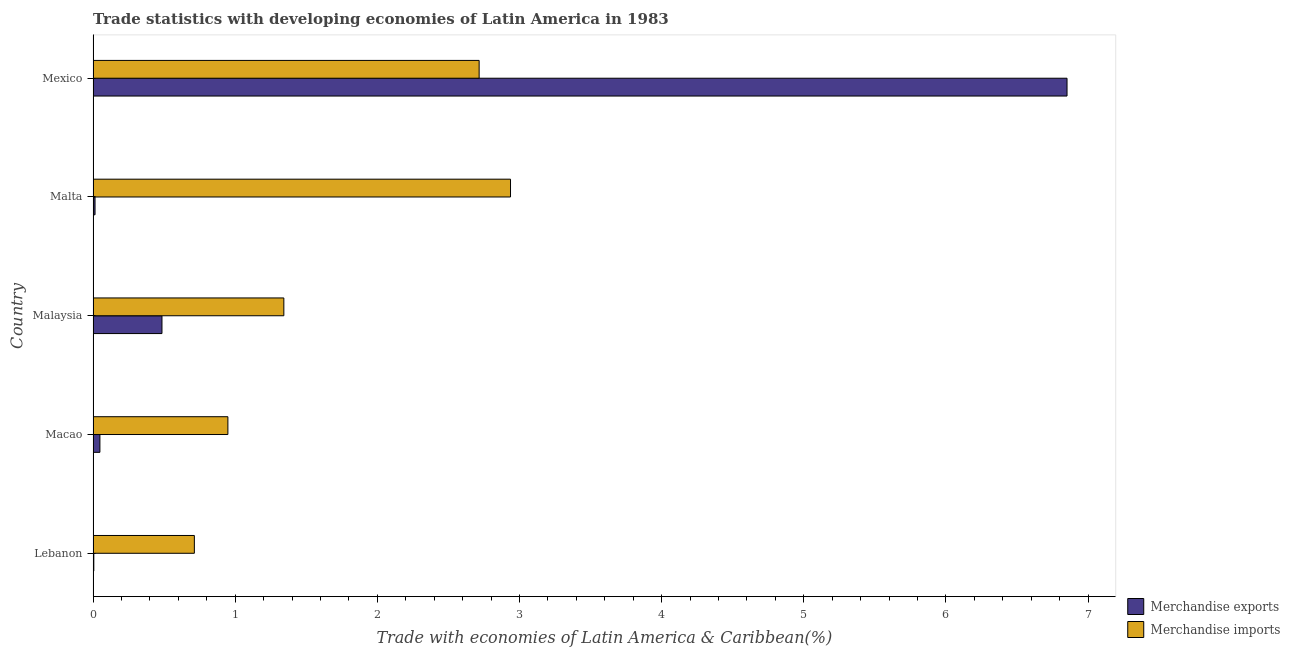Are the number of bars on each tick of the Y-axis equal?
Ensure brevity in your answer.  Yes. How many bars are there on the 2nd tick from the top?
Keep it short and to the point. 2. How many bars are there on the 2nd tick from the bottom?
Provide a succinct answer. 2. What is the label of the 2nd group of bars from the top?
Offer a terse response. Malta. What is the merchandise imports in Malta?
Your answer should be very brief. 2.94. Across all countries, what is the maximum merchandise exports?
Your answer should be compact. 6.85. Across all countries, what is the minimum merchandise exports?
Make the answer very short. 0.01. In which country was the merchandise exports maximum?
Keep it short and to the point. Mexico. In which country was the merchandise exports minimum?
Offer a very short reply. Lebanon. What is the total merchandise imports in the graph?
Provide a succinct answer. 8.66. What is the difference between the merchandise exports in Macao and that in Malaysia?
Keep it short and to the point. -0.44. What is the difference between the merchandise exports in Mexico and the merchandise imports in Malta?
Ensure brevity in your answer.  3.92. What is the average merchandise imports per country?
Your response must be concise. 1.73. What is the difference between the merchandise exports and merchandise imports in Lebanon?
Your response must be concise. -0.71. In how many countries, is the merchandise imports greater than 1.2 %?
Keep it short and to the point. 3. What is the ratio of the merchandise imports in Lebanon to that in Malta?
Ensure brevity in your answer.  0.24. Is the merchandise exports in Macao less than that in Malaysia?
Your response must be concise. Yes. Is the difference between the merchandise imports in Malaysia and Malta greater than the difference between the merchandise exports in Malaysia and Malta?
Your response must be concise. No. What is the difference between the highest and the second highest merchandise imports?
Your answer should be compact. 0.22. What is the difference between the highest and the lowest merchandise imports?
Your answer should be very brief. 2.22. Is the sum of the merchandise imports in Macao and Malaysia greater than the maximum merchandise exports across all countries?
Your answer should be very brief. No. What does the 2nd bar from the bottom in Lebanon represents?
Your answer should be very brief. Merchandise imports. How many countries are there in the graph?
Your response must be concise. 5. What is the difference between two consecutive major ticks on the X-axis?
Keep it short and to the point. 1. Are the values on the major ticks of X-axis written in scientific E-notation?
Offer a very short reply. No. Where does the legend appear in the graph?
Provide a short and direct response. Bottom right. How many legend labels are there?
Make the answer very short. 2. How are the legend labels stacked?
Offer a terse response. Vertical. What is the title of the graph?
Provide a short and direct response. Trade statistics with developing economies of Latin America in 1983. Does "Nitrous oxide" appear as one of the legend labels in the graph?
Make the answer very short. No. What is the label or title of the X-axis?
Keep it short and to the point. Trade with economies of Latin America & Caribbean(%). What is the Trade with economies of Latin America & Caribbean(%) in Merchandise exports in Lebanon?
Offer a terse response. 0.01. What is the Trade with economies of Latin America & Caribbean(%) in Merchandise imports in Lebanon?
Provide a succinct answer. 0.71. What is the Trade with economies of Latin America & Caribbean(%) in Merchandise exports in Macao?
Ensure brevity in your answer.  0.05. What is the Trade with economies of Latin America & Caribbean(%) in Merchandise imports in Macao?
Ensure brevity in your answer.  0.95. What is the Trade with economies of Latin America & Caribbean(%) of Merchandise exports in Malaysia?
Your answer should be compact. 0.48. What is the Trade with economies of Latin America & Caribbean(%) in Merchandise imports in Malaysia?
Make the answer very short. 1.34. What is the Trade with economies of Latin America & Caribbean(%) in Merchandise exports in Malta?
Your answer should be compact. 0.01. What is the Trade with economies of Latin America & Caribbean(%) in Merchandise imports in Malta?
Make the answer very short. 2.94. What is the Trade with economies of Latin America & Caribbean(%) of Merchandise exports in Mexico?
Your answer should be very brief. 6.85. What is the Trade with economies of Latin America & Caribbean(%) of Merchandise imports in Mexico?
Your answer should be very brief. 2.72. Across all countries, what is the maximum Trade with economies of Latin America & Caribbean(%) of Merchandise exports?
Provide a succinct answer. 6.85. Across all countries, what is the maximum Trade with economies of Latin America & Caribbean(%) of Merchandise imports?
Your response must be concise. 2.94. Across all countries, what is the minimum Trade with economies of Latin America & Caribbean(%) in Merchandise exports?
Make the answer very short. 0.01. Across all countries, what is the minimum Trade with economies of Latin America & Caribbean(%) in Merchandise imports?
Provide a succinct answer. 0.71. What is the total Trade with economies of Latin America & Caribbean(%) of Merchandise exports in the graph?
Your answer should be very brief. 7.4. What is the total Trade with economies of Latin America & Caribbean(%) in Merchandise imports in the graph?
Provide a short and direct response. 8.66. What is the difference between the Trade with economies of Latin America & Caribbean(%) of Merchandise exports in Lebanon and that in Macao?
Provide a short and direct response. -0.04. What is the difference between the Trade with economies of Latin America & Caribbean(%) of Merchandise imports in Lebanon and that in Macao?
Your response must be concise. -0.24. What is the difference between the Trade with economies of Latin America & Caribbean(%) in Merchandise exports in Lebanon and that in Malaysia?
Make the answer very short. -0.48. What is the difference between the Trade with economies of Latin America & Caribbean(%) in Merchandise imports in Lebanon and that in Malaysia?
Ensure brevity in your answer.  -0.63. What is the difference between the Trade with economies of Latin America & Caribbean(%) in Merchandise exports in Lebanon and that in Malta?
Ensure brevity in your answer.  -0.01. What is the difference between the Trade with economies of Latin America & Caribbean(%) in Merchandise imports in Lebanon and that in Malta?
Your answer should be very brief. -2.22. What is the difference between the Trade with economies of Latin America & Caribbean(%) in Merchandise exports in Lebanon and that in Mexico?
Offer a very short reply. -6.85. What is the difference between the Trade with economies of Latin America & Caribbean(%) in Merchandise imports in Lebanon and that in Mexico?
Offer a terse response. -2. What is the difference between the Trade with economies of Latin America & Caribbean(%) in Merchandise exports in Macao and that in Malaysia?
Offer a terse response. -0.44. What is the difference between the Trade with economies of Latin America & Caribbean(%) in Merchandise imports in Macao and that in Malaysia?
Offer a very short reply. -0.39. What is the difference between the Trade with economies of Latin America & Caribbean(%) in Merchandise exports in Macao and that in Malta?
Your response must be concise. 0.03. What is the difference between the Trade with economies of Latin America & Caribbean(%) in Merchandise imports in Macao and that in Malta?
Offer a very short reply. -1.99. What is the difference between the Trade with economies of Latin America & Caribbean(%) of Merchandise exports in Macao and that in Mexico?
Provide a short and direct response. -6.8. What is the difference between the Trade with economies of Latin America & Caribbean(%) in Merchandise imports in Macao and that in Mexico?
Your response must be concise. -1.77. What is the difference between the Trade with economies of Latin America & Caribbean(%) of Merchandise exports in Malaysia and that in Malta?
Offer a terse response. 0.47. What is the difference between the Trade with economies of Latin America & Caribbean(%) of Merchandise imports in Malaysia and that in Malta?
Offer a very short reply. -1.59. What is the difference between the Trade with economies of Latin America & Caribbean(%) of Merchandise exports in Malaysia and that in Mexico?
Your answer should be very brief. -6.37. What is the difference between the Trade with economies of Latin America & Caribbean(%) of Merchandise imports in Malaysia and that in Mexico?
Provide a succinct answer. -1.37. What is the difference between the Trade with economies of Latin America & Caribbean(%) of Merchandise exports in Malta and that in Mexico?
Provide a succinct answer. -6.84. What is the difference between the Trade with economies of Latin America & Caribbean(%) of Merchandise imports in Malta and that in Mexico?
Ensure brevity in your answer.  0.22. What is the difference between the Trade with economies of Latin America & Caribbean(%) of Merchandise exports in Lebanon and the Trade with economies of Latin America & Caribbean(%) of Merchandise imports in Macao?
Your answer should be compact. -0.94. What is the difference between the Trade with economies of Latin America & Caribbean(%) in Merchandise exports in Lebanon and the Trade with economies of Latin America & Caribbean(%) in Merchandise imports in Malaysia?
Offer a very short reply. -1.34. What is the difference between the Trade with economies of Latin America & Caribbean(%) in Merchandise exports in Lebanon and the Trade with economies of Latin America & Caribbean(%) in Merchandise imports in Malta?
Give a very brief answer. -2.93. What is the difference between the Trade with economies of Latin America & Caribbean(%) of Merchandise exports in Lebanon and the Trade with economies of Latin America & Caribbean(%) of Merchandise imports in Mexico?
Provide a short and direct response. -2.71. What is the difference between the Trade with economies of Latin America & Caribbean(%) in Merchandise exports in Macao and the Trade with economies of Latin America & Caribbean(%) in Merchandise imports in Malaysia?
Offer a very short reply. -1.29. What is the difference between the Trade with economies of Latin America & Caribbean(%) in Merchandise exports in Macao and the Trade with economies of Latin America & Caribbean(%) in Merchandise imports in Malta?
Provide a succinct answer. -2.89. What is the difference between the Trade with economies of Latin America & Caribbean(%) of Merchandise exports in Macao and the Trade with economies of Latin America & Caribbean(%) of Merchandise imports in Mexico?
Your response must be concise. -2.67. What is the difference between the Trade with economies of Latin America & Caribbean(%) of Merchandise exports in Malaysia and the Trade with economies of Latin America & Caribbean(%) of Merchandise imports in Malta?
Give a very brief answer. -2.45. What is the difference between the Trade with economies of Latin America & Caribbean(%) in Merchandise exports in Malaysia and the Trade with economies of Latin America & Caribbean(%) in Merchandise imports in Mexico?
Your answer should be very brief. -2.23. What is the difference between the Trade with economies of Latin America & Caribbean(%) in Merchandise exports in Malta and the Trade with economies of Latin America & Caribbean(%) in Merchandise imports in Mexico?
Make the answer very short. -2.7. What is the average Trade with economies of Latin America & Caribbean(%) in Merchandise exports per country?
Give a very brief answer. 1.48. What is the average Trade with economies of Latin America & Caribbean(%) in Merchandise imports per country?
Make the answer very short. 1.73. What is the difference between the Trade with economies of Latin America & Caribbean(%) of Merchandise exports and Trade with economies of Latin America & Caribbean(%) of Merchandise imports in Lebanon?
Keep it short and to the point. -0.71. What is the difference between the Trade with economies of Latin America & Caribbean(%) in Merchandise exports and Trade with economies of Latin America & Caribbean(%) in Merchandise imports in Macao?
Make the answer very short. -0.9. What is the difference between the Trade with economies of Latin America & Caribbean(%) of Merchandise exports and Trade with economies of Latin America & Caribbean(%) of Merchandise imports in Malaysia?
Ensure brevity in your answer.  -0.86. What is the difference between the Trade with economies of Latin America & Caribbean(%) in Merchandise exports and Trade with economies of Latin America & Caribbean(%) in Merchandise imports in Malta?
Offer a very short reply. -2.92. What is the difference between the Trade with economies of Latin America & Caribbean(%) of Merchandise exports and Trade with economies of Latin America & Caribbean(%) of Merchandise imports in Mexico?
Your answer should be compact. 4.14. What is the ratio of the Trade with economies of Latin America & Caribbean(%) in Merchandise exports in Lebanon to that in Macao?
Your answer should be very brief. 0.11. What is the ratio of the Trade with economies of Latin America & Caribbean(%) of Merchandise imports in Lebanon to that in Macao?
Make the answer very short. 0.75. What is the ratio of the Trade with economies of Latin America & Caribbean(%) of Merchandise exports in Lebanon to that in Malaysia?
Provide a short and direct response. 0.01. What is the ratio of the Trade with economies of Latin America & Caribbean(%) of Merchandise imports in Lebanon to that in Malaysia?
Your answer should be compact. 0.53. What is the ratio of the Trade with economies of Latin America & Caribbean(%) in Merchandise exports in Lebanon to that in Malta?
Your answer should be compact. 0.37. What is the ratio of the Trade with economies of Latin America & Caribbean(%) of Merchandise imports in Lebanon to that in Malta?
Keep it short and to the point. 0.24. What is the ratio of the Trade with economies of Latin America & Caribbean(%) in Merchandise exports in Lebanon to that in Mexico?
Make the answer very short. 0. What is the ratio of the Trade with economies of Latin America & Caribbean(%) in Merchandise imports in Lebanon to that in Mexico?
Provide a short and direct response. 0.26. What is the ratio of the Trade with economies of Latin America & Caribbean(%) in Merchandise exports in Macao to that in Malaysia?
Give a very brief answer. 0.1. What is the ratio of the Trade with economies of Latin America & Caribbean(%) in Merchandise imports in Macao to that in Malaysia?
Offer a very short reply. 0.71. What is the ratio of the Trade with economies of Latin America & Caribbean(%) of Merchandise exports in Macao to that in Malta?
Keep it short and to the point. 3.49. What is the ratio of the Trade with economies of Latin America & Caribbean(%) in Merchandise imports in Macao to that in Malta?
Your response must be concise. 0.32. What is the ratio of the Trade with economies of Latin America & Caribbean(%) of Merchandise exports in Macao to that in Mexico?
Your answer should be very brief. 0.01. What is the ratio of the Trade with economies of Latin America & Caribbean(%) in Merchandise imports in Macao to that in Mexico?
Your answer should be very brief. 0.35. What is the ratio of the Trade with economies of Latin America & Caribbean(%) in Merchandise exports in Malaysia to that in Malta?
Your response must be concise. 35.22. What is the ratio of the Trade with economies of Latin America & Caribbean(%) in Merchandise imports in Malaysia to that in Malta?
Provide a short and direct response. 0.46. What is the ratio of the Trade with economies of Latin America & Caribbean(%) of Merchandise exports in Malaysia to that in Mexico?
Provide a succinct answer. 0.07. What is the ratio of the Trade with economies of Latin America & Caribbean(%) in Merchandise imports in Malaysia to that in Mexico?
Give a very brief answer. 0.49. What is the ratio of the Trade with economies of Latin America & Caribbean(%) of Merchandise exports in Malta to that in Mexico?
Ensure brevity in your answer.  0. What is the ratio of the Trade with economies of Latin America & Caribbean(%) of Merchandise imports in Malta to that in Mexico?
Offer a very short reply. 1.08. What is the difference between the highest and the second highest Trade with economies of Latin America & Caribbean(%) in Merchandise exports?
Offer a terse response. 6.37. What is the difference between the highest and the second highest Trade with economies of Latin America & Caribbean(%) of Merchandise imports?
Offer a terse response. 0.22. What is the difference between the highest and the lowest Trade with economies of Latin America & Caribbean(%) in Merchandise exports?
Give a very brief answer. 6.85. What is the difference between the highest and the lowest Trade with economies of Latin America & Caribbean(%) in Merchandise imports?
Keep it short and to the point. 2.22. 